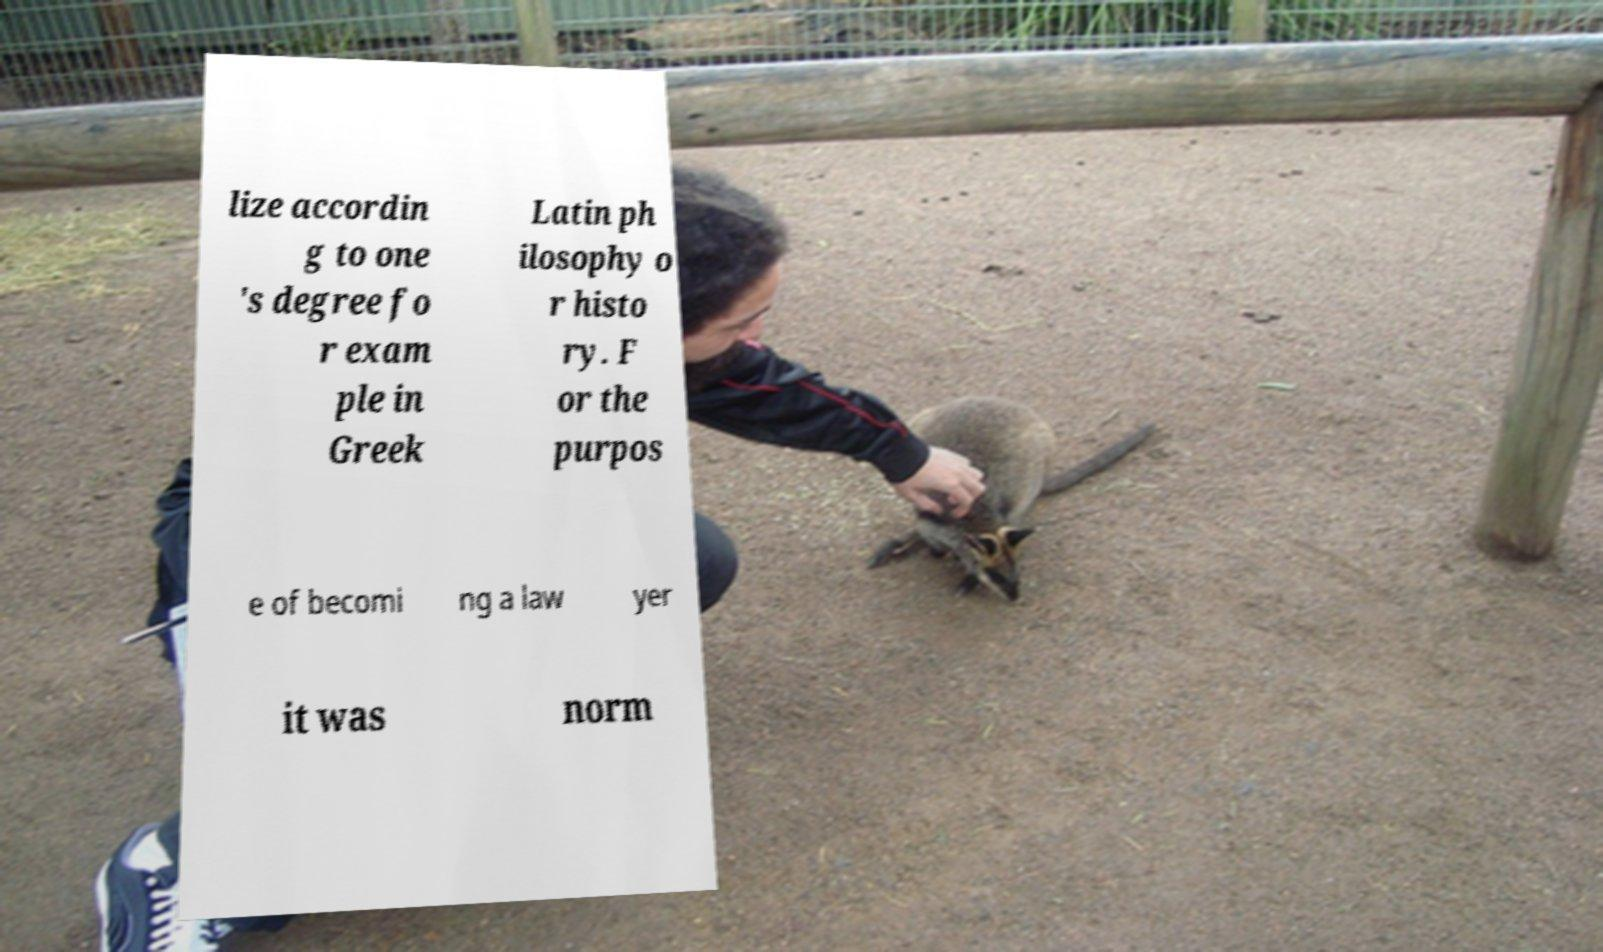Can you accurately transcribe the text from the provided image for me? lize accordin g to one 's degree fo r exam ple in Greek Latin ph ilosophy o r histo ry. F or the purpos e of becomi ng a law yer it was norm 